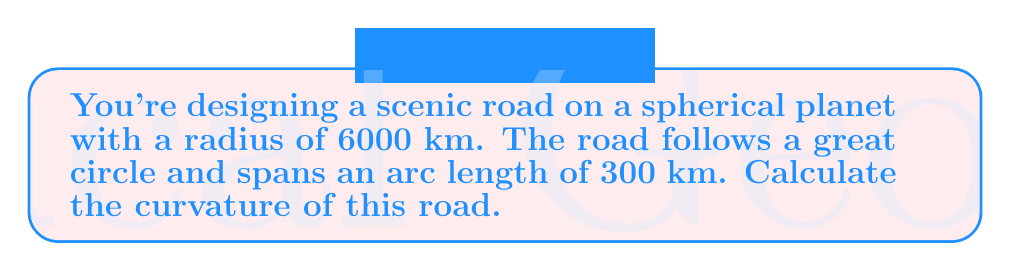Could you help me with this problem? Let's approach this step-by-step:

1) The curvature of a curve on a sphere is defined as the reciprocal of the radius of the sphere. In this case, we're dealing with a great circle, which has the same radius as the sphere itself.

2) Given:
   - Radius of the planet (sphere): $R = 6000$ km
   - Arc length of the road: $s = 300$ km

3) The curvature $\kappa$ of a great circle on a sphere is given by:

   $$\kappa = \frac{1}{R}$$

4) Substituting the given radius:

   $$\kappa = \frac{1}{6000} \text{ km}^{-1}$$

5) To express this in standard units, let's convert to meters:

   $$\kappa = \frac{1}{6,000,000} \text{ m}^{-1}$$

6) This can also be expressed as $1.67 \times 10^{-7} \text{ m}^{-1}$

Note: The arc length of the road doesn't affect the curvature calculation in this case, as the curvature is constant for a great circle on a sphere. However, it's relevant information for a road safety perspective, as it gives an idea of the length over which this constant curvature is maintained.
Answer: $1.67 \times 10^{-7} \text{ m}^{-1}$ 